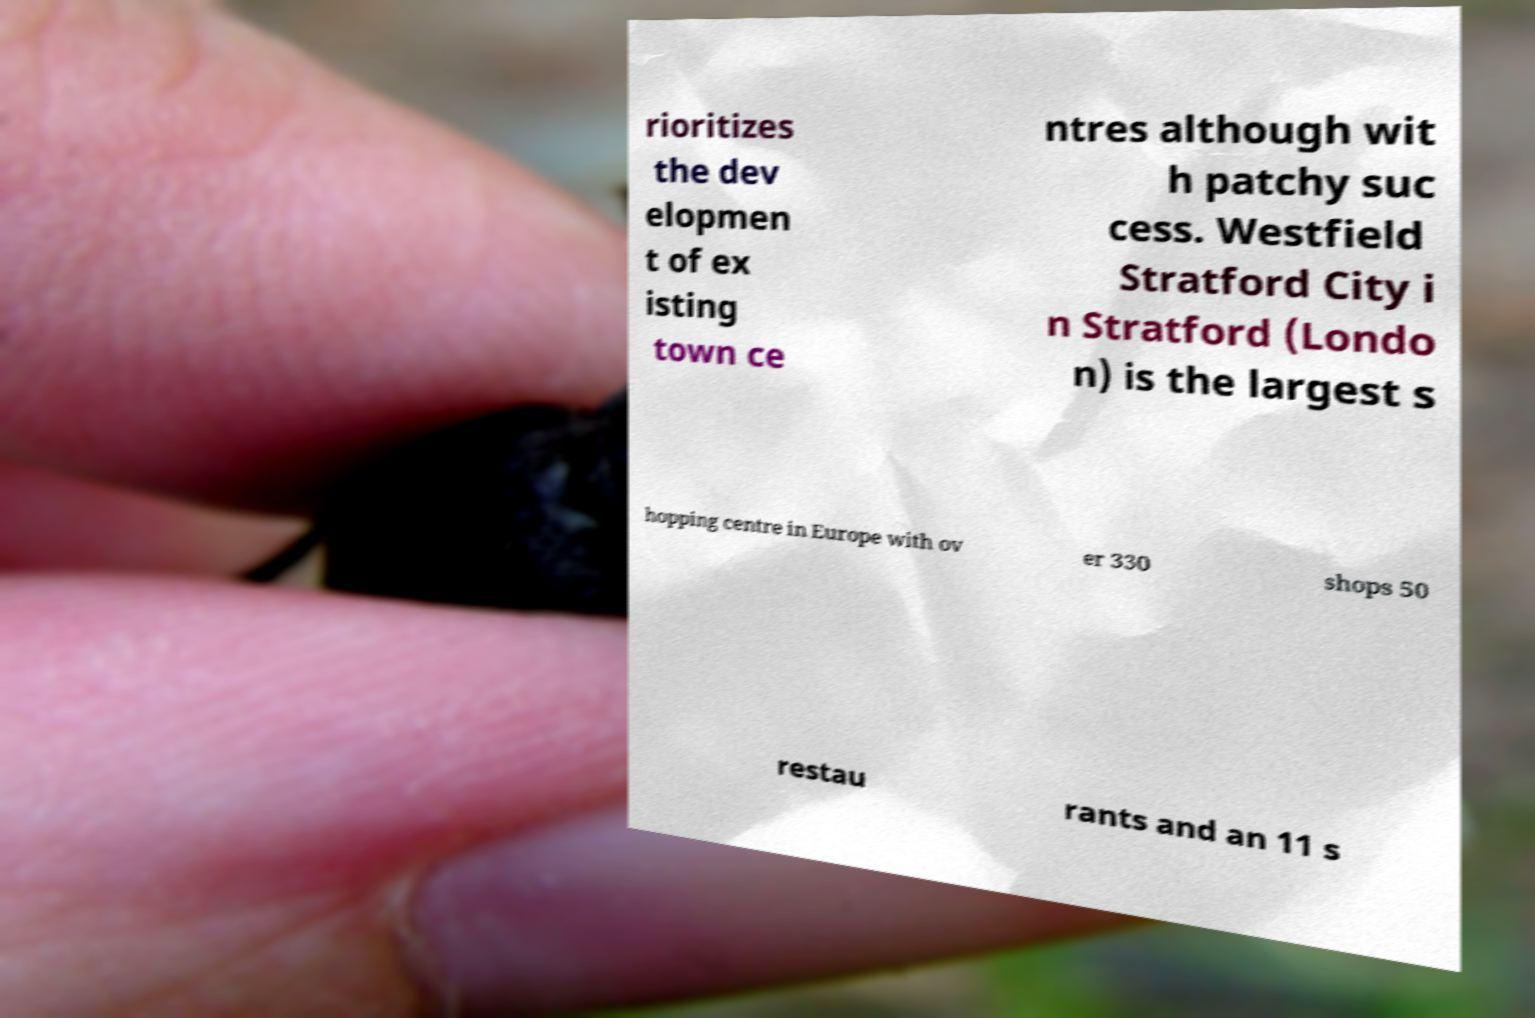I need the written content from this picture converted into text. Can you do that? rioritizes the dev elopmen t of ex isting town ce ntres although wit h patchy suc cess. Westfield Stratford City i n Stratford (Londo n) is the largest s hopping centre in Europe with ov er 330 shops 50 restau rants and an 11 s 